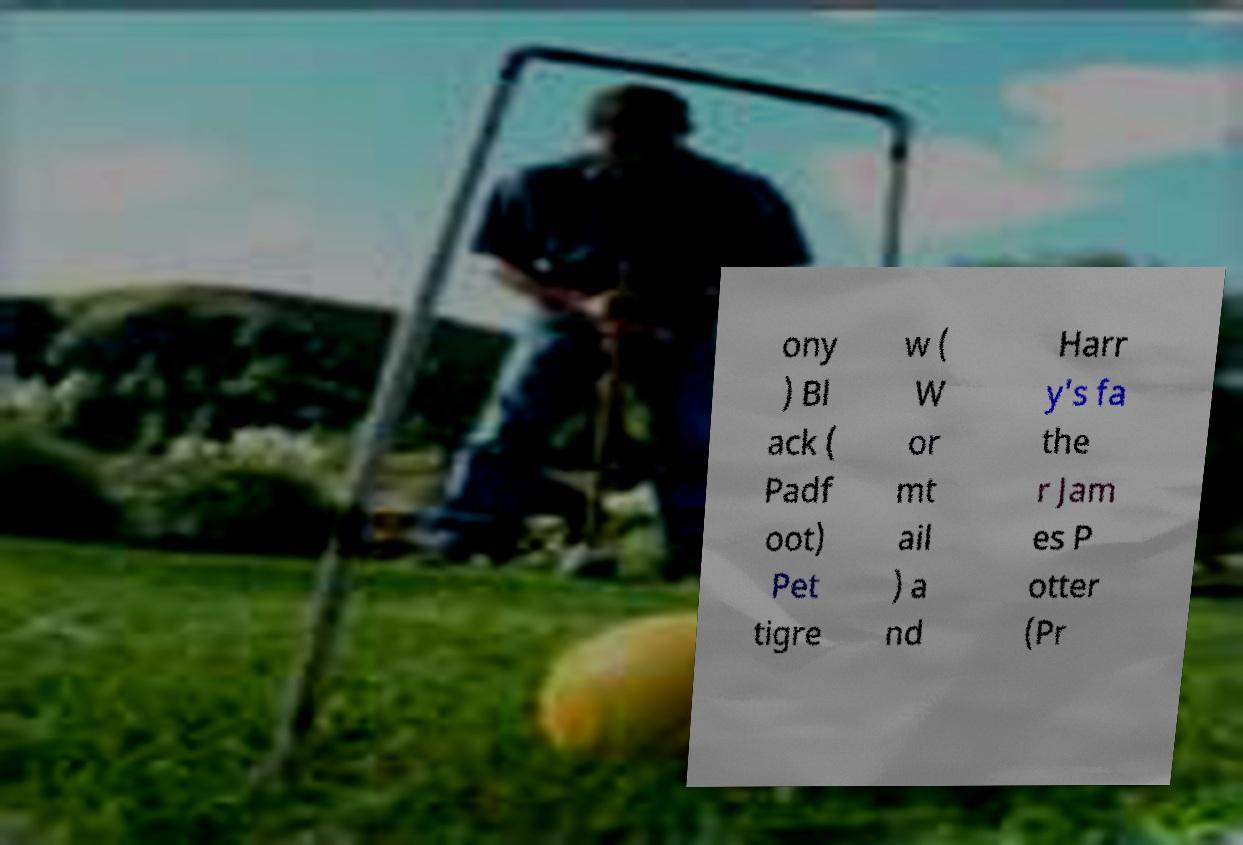Could you assist in decoding the text presented in this image and type it out clearly? ony ) Bl ack ( Padf oot) Pet tigre w ( W or mt ail ) a nd Harr y's fa the r Jam es P otter (Pr 